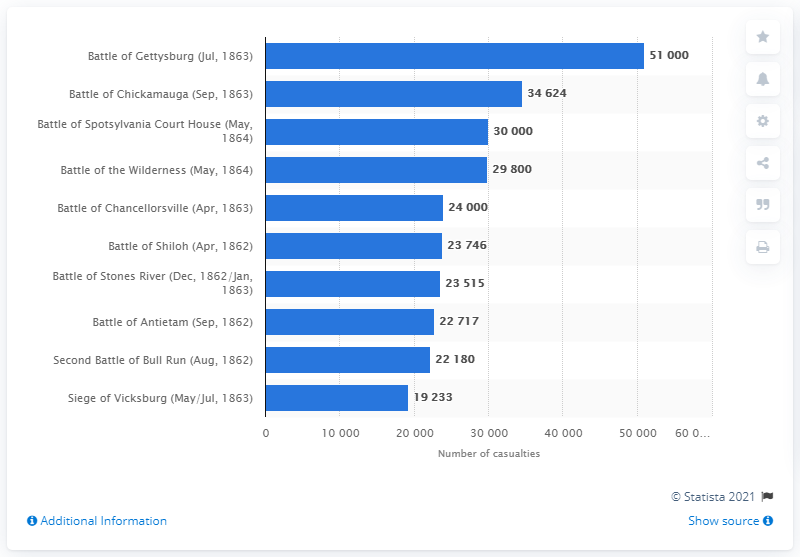List a handful of essential elements in this visual. The Battle of Gettysburg resulted in a significant loss of life, with approximately 51,000 casualties. 